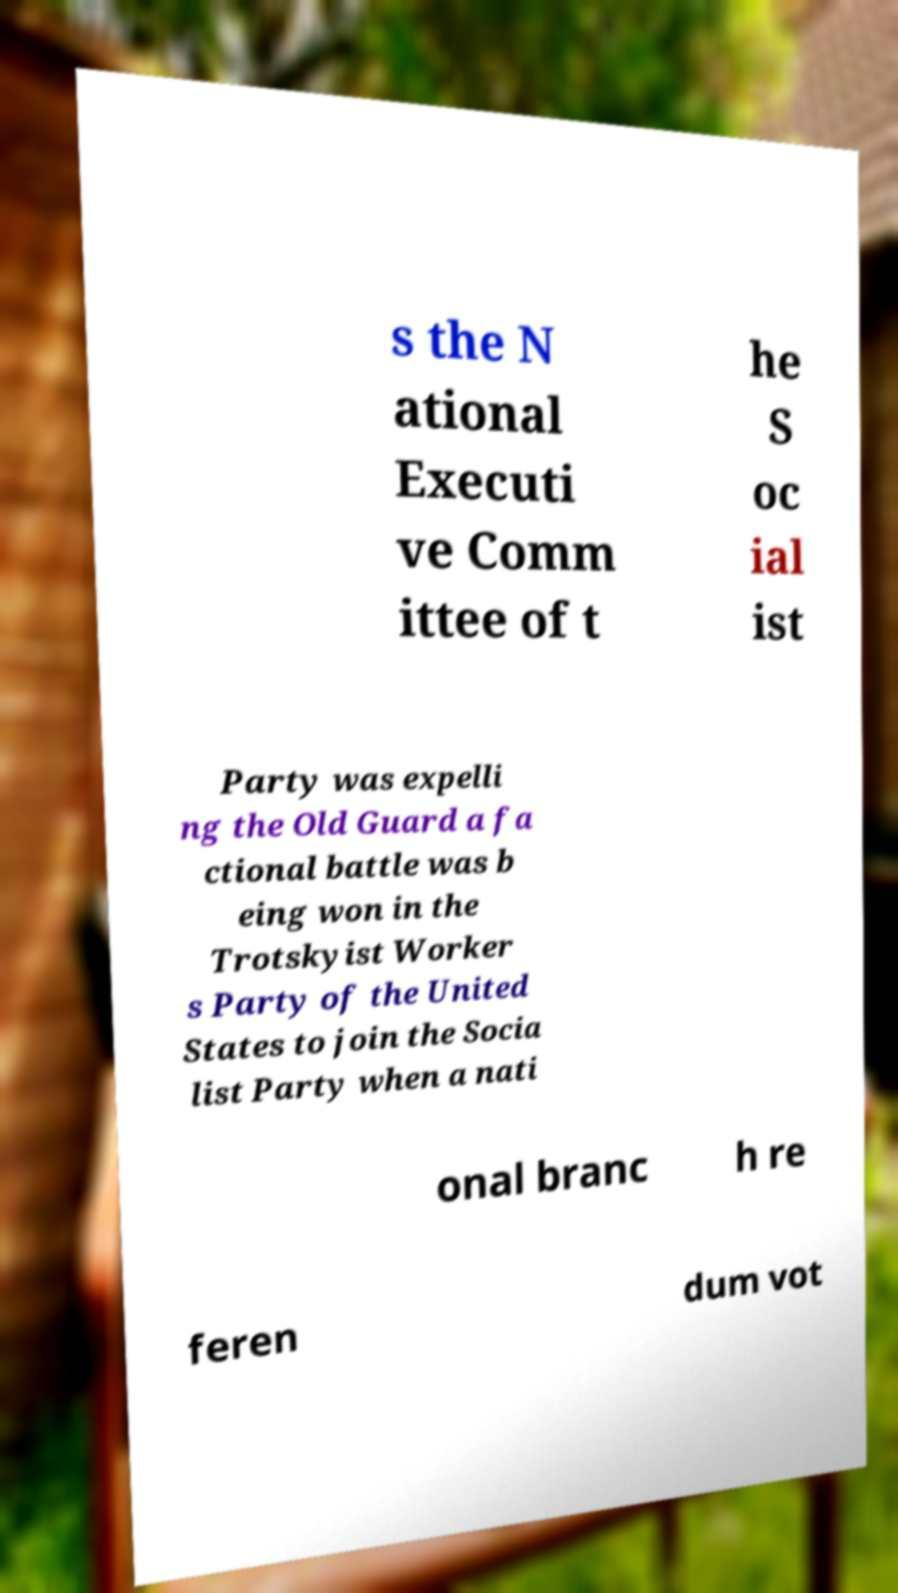Please read and relay the text visible in this image. What does it say? s the N ational Executi ve Comm ittee of t he S oc ial ist Party was expelli ng the Old Guard a fa ctional battle was b eing won in the Trotskyist Worker s Party of the United States to join the Socia list Party when a nati onal branc h re feren dum vot 